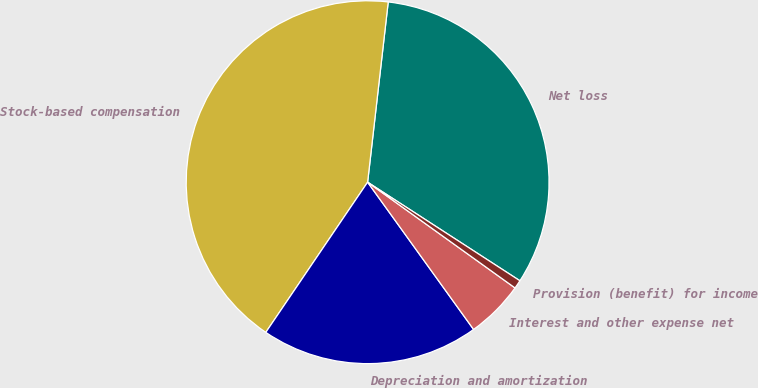<chart> <loc_0><loc_0><loc_500><loc_500><pie_chart><fcel>Net loss<fcel>Stock-based compensation<fcel>Depreciation and amortization<fcel>Interest and other expense net<fcel>Provision (benefit) for income<nl><fcel>32.33%<fcel>42.33%<fcel>19.41%<fcel>5.17%<fcel>0.76%<nl></chart> 